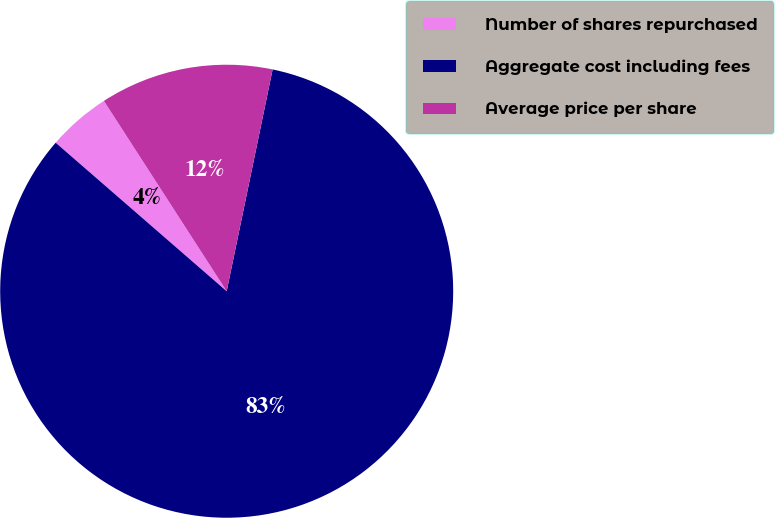Convert chart to OTSL. <chart><loc_0><loc_0><loc_500><loc_500><pie_chart><fcel>Number of shares repurchased<fcel>Aggregate cost including fees<fcel>Average price per share<nl><fcel>4.5%<fcel>83.13%<fcel>12.37%<nl></chart> 